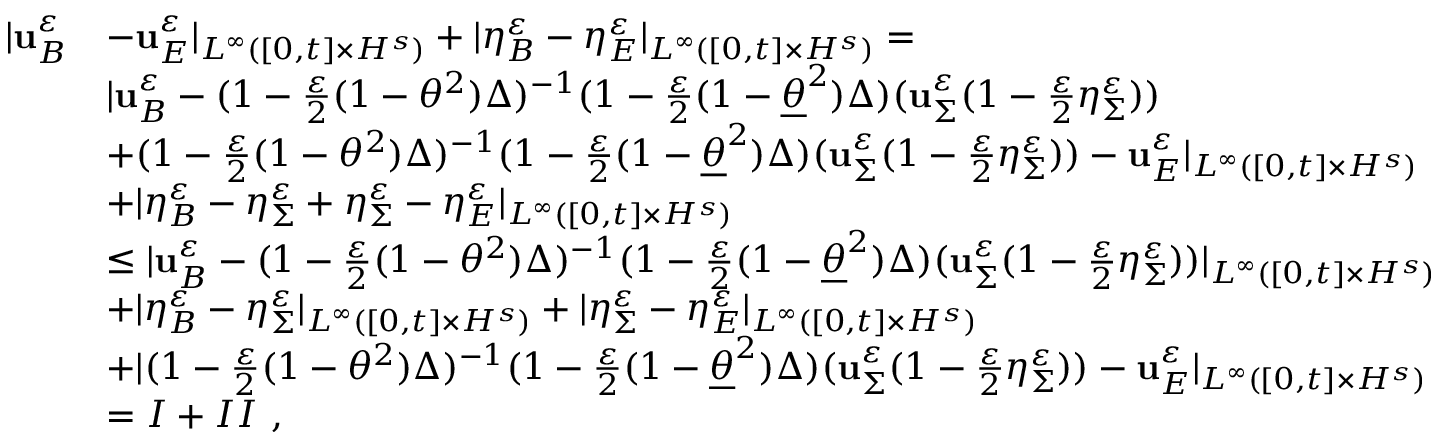Convert formula to latex. <formula><loc_0><loc_0><loc_500><loc_500>\begin{array} { r l } { | u _ { B } ^ { \varepsilon } } & { - u _ { E } ^ { \varepsilon } | _ { L ^ { \infty } ( [ 0 , t ] \times H ^ { s } ) } + | \eta _ { B } ^ { \varepsilon } - \eta _ { E } ^ { \varepsilon } | _ { L ^ { \infty } ( [ 0 , t ] \times H ^ { s } ) } = } \\ & { | u _ { B } ^ { \varepsilon } - ( 1 - \frac { \varepsilon } { 2 } ( 1 - \theta ^ { 2 } ) \Delta ) ^ { - 1 } ( 1 - \frac { \varepsilon } { 2 } ( 1 - \underline { \theta } ^ { 2 } ) \Delta ) ( u _ { \Sigma } ^ { \varepsilon } ( 1 - \frac { \varepsilon } { 2 } \eta _ { \Sigma } ^ { \varepsilon } ) ) } \\ & { + ( 1 - \frac { \varepsilon } { 2 } ( 1 - \theta ^ { 2 } ) \Delta ) ^ { - 1 } ( 1 - \frac { \varepsilon } { 2 } ( 1 - \underline { \theta } ^ { 2 } ) \Delta ) ( u _ { \Sigma } ^ { \varepsilon } ( 1 - \frac { \varepsilon } { 2 } \eta _ { \Sigma } ^ { \varepsilon } ) ) - u _ { E } ^ { \varepsilon } | _ { L ^ { \infty } ( [ 0 , t ] \times H ^ { s } ) } } \\ & { + | \eta _ { B } ^ { \varepsilon } - \eta _ { \Sigma } ^ { \varepsilon } + \eta _ { \Sigma } ^ { \varepsilon } - \eta _ { E } ^ { \varepsilon } | _ { L ^ { \infty } ( [ 0 , t ] \times H ^ { s } ) } } \\ & { \leq | u _ { B } ^ { \varepsilon } - ( 1 - \frac { \varepsilon } { 2 } ( 1 - \theta ^ { 2 } ) \Delta ) ^ { - 1 } ( 1 - \frac { \varepsilon } { 2 } ( 1 - \underline { \theta } ^ { 2 } ) \Delta ) ( u _ { \Sigma } ^ { \varepsilon } ( 1 - \frac { \varepsilon } { 2 } \eta _ { \Sigma } ^ { \varepsilon } ) ) | _ { L ^ { \infty } ( [ 0 , t ] \times H ^ { s } ) } } \\ & { + | \eta _ { B } ^ { \varepsilon } - \eta _ { \Sigma } ^ { \varepsilon } | _ { L ^ { \infty } ( [ 0 , t ] \times H ^ { s } ) } + | \eta _ { \Sigma } ^ { \varepsilon } - \eta _ { E } ^ { \varepsilon } | _ { L ^ { \infty } ( [ 0 , t ] \times H ^ { s } ) } } \\ & { + | ( 1 - \frac { \varepsilon } { 2 } ( 1 - \theta ^ { 2 } ) \Delta ) ^ { - 1 } ( 1 - \frac { \varepsilon } { 2 } ( 1 - \underline { \theta } ^ { 2 } ) \Delta ) ( u _ { \Sigma } ^ { \varepsilon } ( 1 - \frac { \varepsilon } { 2 } \eta _ { \Sigma } ^ { \varepsilon } ) ) - u _ { E } ^ { \varepsilon } | _ { L ^ { \infty } ( [ 0 , t ] \times H ^ { s } ) } } \\ & { = I + I I \ , } \end{array}</formula> 